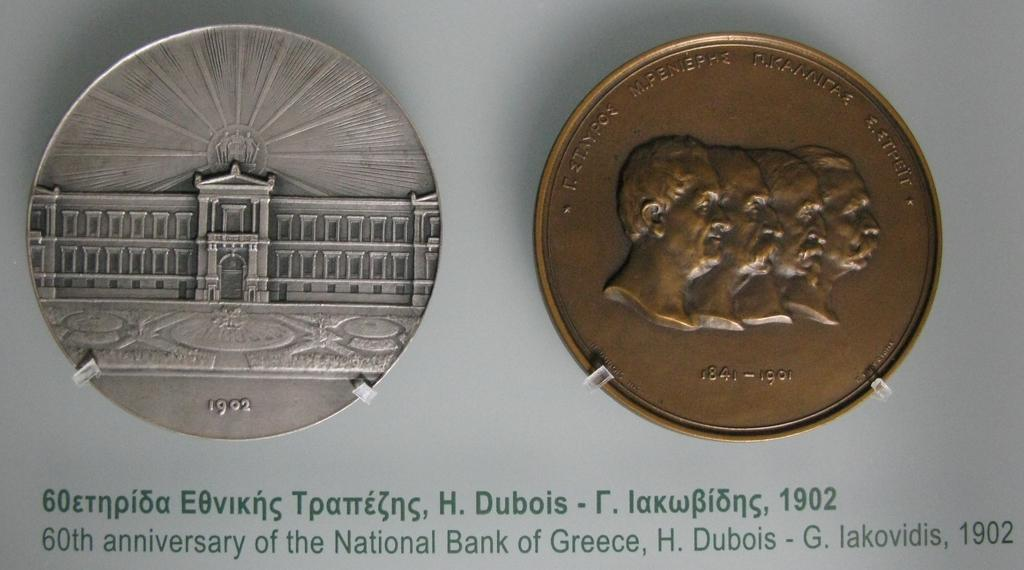<image>
Write a terse but informative summary of the picture. A silver coin from 1902 next to a copper coin from 1841-1901. 